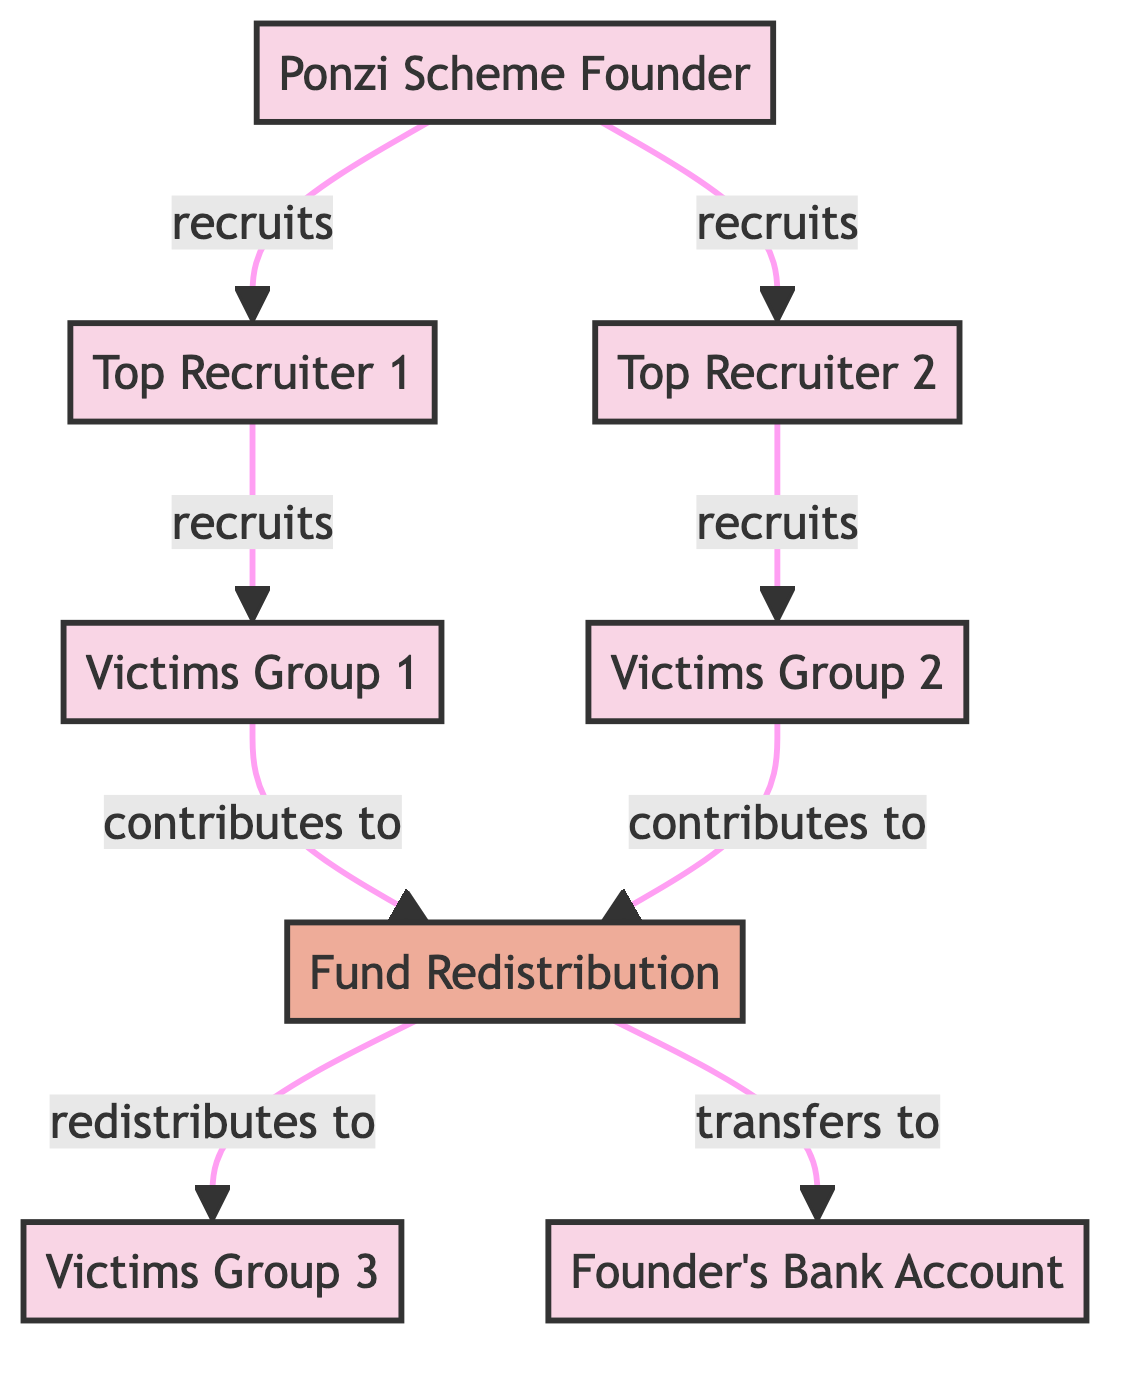What is the total number of nodes in the diagram? The diagram includes the following nodes: Ponzi Scheme Founder, Top Recruiter 1, Top Recruiter 2, Victims Group 1, Victims Group 2, Victims Group 3, Fund Redistribution, and Founder’s Bank Account. Counting these gives a total of 8 nodes.
Answer: 8 Who recruits Top Recruiter 2? The diagram shows an arrow from Ponzi Scheme Founder to Top Recruiter 2 with the label "recruits", indicating that the founder is the one who recruits Top Recruiter 2.
Answer: Ponzi Scheme Founder How many victim groups contribute to fund redistribution? The diagram indicates two arrows leading from Victims Group 1 and Victims Group 2 to Fund Redistribution, which shows that both groups contribute to the fund. Thus, there are a total of 2 victim groups that contribute.
Answer: 2 What is the relationship between Fund Redistribution and Victims Group 3? The diagram indicates a directed edge from Fund Redistribution to Victims Group 3 labeled "redistributes to", which directly defines the relationship as redistribution of funds to this group.
Answer: redistributes to Which group is recruited by Top Recruiter 1? The diagram shows an arrow labeled "recruits" leading from Top Recruiter 1 to Victims Group 1, directly indicating this recruitment relationship.
Answer: Victims Group 1 What action does the Fund Redistribution take toward the Founder’s Bank Account? The diagram depicts an arrow from Fund Redistribution to the Founder’s Bank Account labeled "transfers to", which clearly states the action taken by the fund redistribution process.
Answer: transfers to Who are the two top recruiters in the scheme? The diagram shows two figures labeled as Top Recruiter 1 and Top Recruiter 2, both clearly identified in the node list. Thus, these are the top recruiters.
Answer: Top Recruiter 1 and Top Recruiter 2 Explain how Victims Group 3 receives funds. The diagram shows that Victims Group 3 is linked to Fund Redistribution through the relationship "redistributes to". Before receiving funds, Victims Group 1 and Victims Group 2 contribute to the Fund Redistribution, indicating that Victims Group 3 ultimately benefits from the reallocation of those contributions.
Answer: through Fund Redistribution 